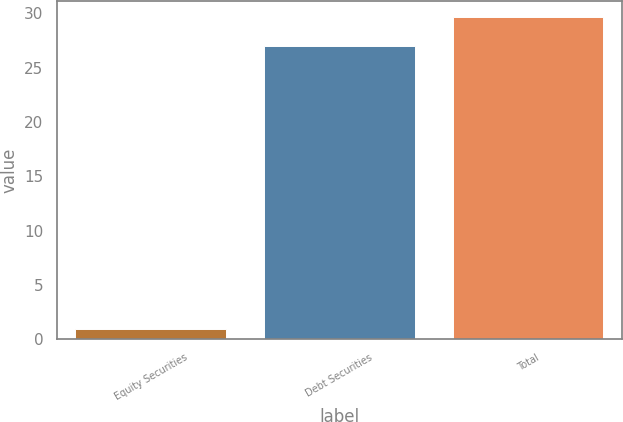<chart> <loc_0><loc_0><loc_500><loc_500><bar_chart><fcel>Equity Securities<fcel>Debt Securities<fcel>Total<nl><fcel>1<fcel>27<fcel>29.7<nl></chart> 